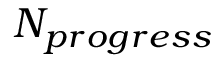Convert formula to latex. <formula><loc_0><loc_0><loc_500><loc_500>N _ { p r o g r e s s }</formula> 